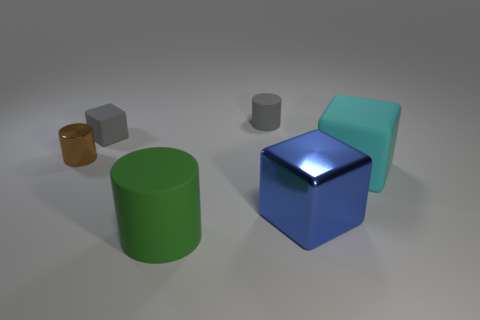Are there more large green matte cylinders that are left of the large matte cylinder than blocks to the left of the big metallic block?
Offer a very short reply. No. There is a thing that is on the left side of the big metallic object and to the right of the big green object; what is its size?
Make the answer very short. Small. How many gray matte objects have the same size as the brown metallic thing?
Your response must be concise. 2. There is a tiny thing that is the same color as the small rubber cylinder; what is its material?
Give a very brief answer. Rubber. There is a metallic thing that is to the right of the tiny brown object; does it have the same shape as the green rubber object?
Offer a terse response. No. Is the number of small cylinders left of the large green matte cylinder less than the number of big metal cubes?
Your answer should be compact. No. Are there any big cylinders of the same color as the tiny rubber block?
Your response must be concise. No. There is a big blue metallic thing; is its shape the same as the tiny object that is on the right side of the green object?
Offer a very short reply. No. Is there a ball that has the same material as the green cylinder?
Your response must be concise. No. There is a tiny cylinder that is in front of the rubber block that is behind the brown object; is there a small cylinder that is behind it?
Offer a terse response. Yes. 